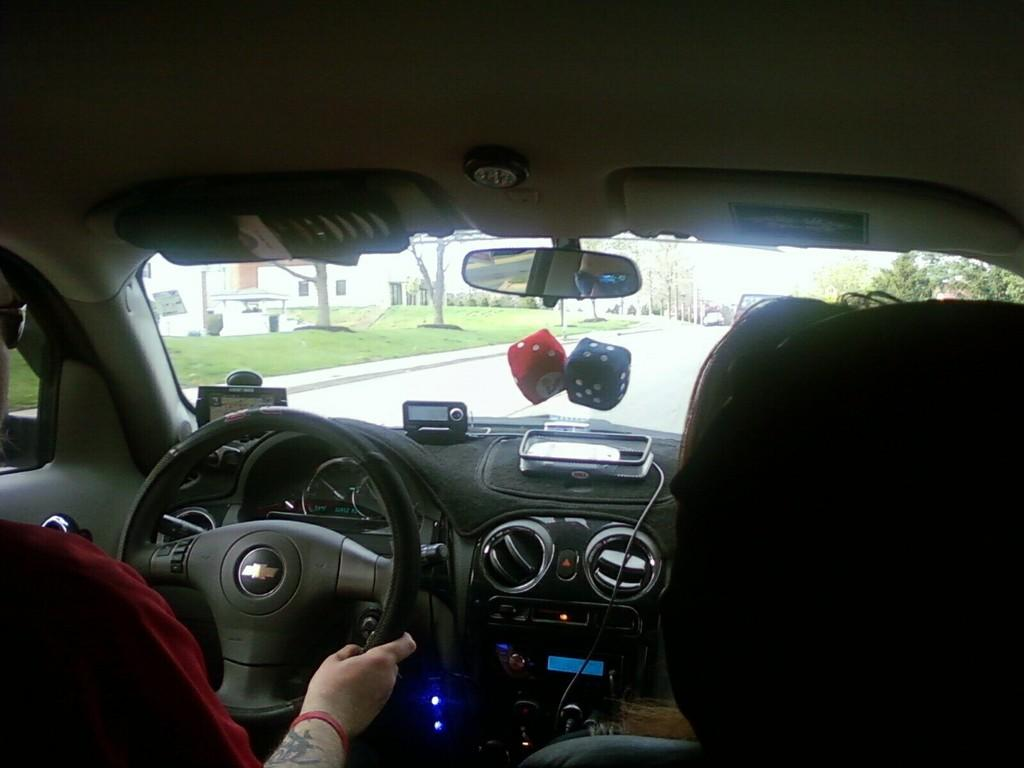What type of environment is visible inside the vehicle? The inside of a vehicle is visible in the image. What is the person in the image doing? The person is holding a steering wheel. What can be seen outside the vehicle through the windows? Trees, a building, and a road are visible through the vehicle. What type of vegetation is present on the ground outside the vehicle? Grass is present on the ground outside the vehicle. Can you tell me how many frogs are sitting on the authority figure's hat in the image? There are no frogs or authority figures present in the image; it shows the inside of a vehicle with a person holding a steering wheel. What type of bat is flying near the building visible through the vehicle? There are no bats visible in the image; it only shows trees, a building, and a road outside the vehicle. 